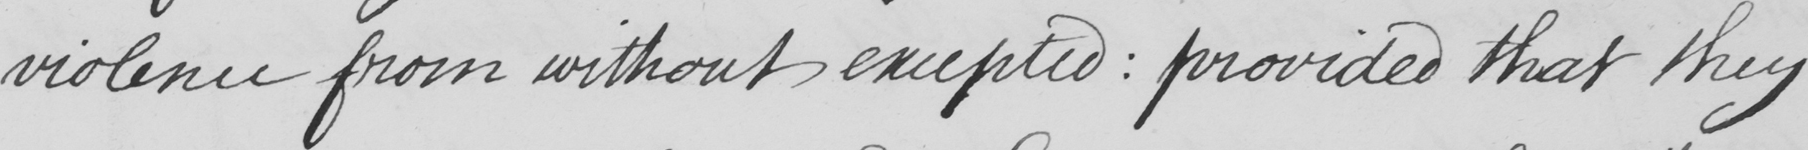Can you read and transcribe this handwriting? violence from without excepted  :  provided that they 